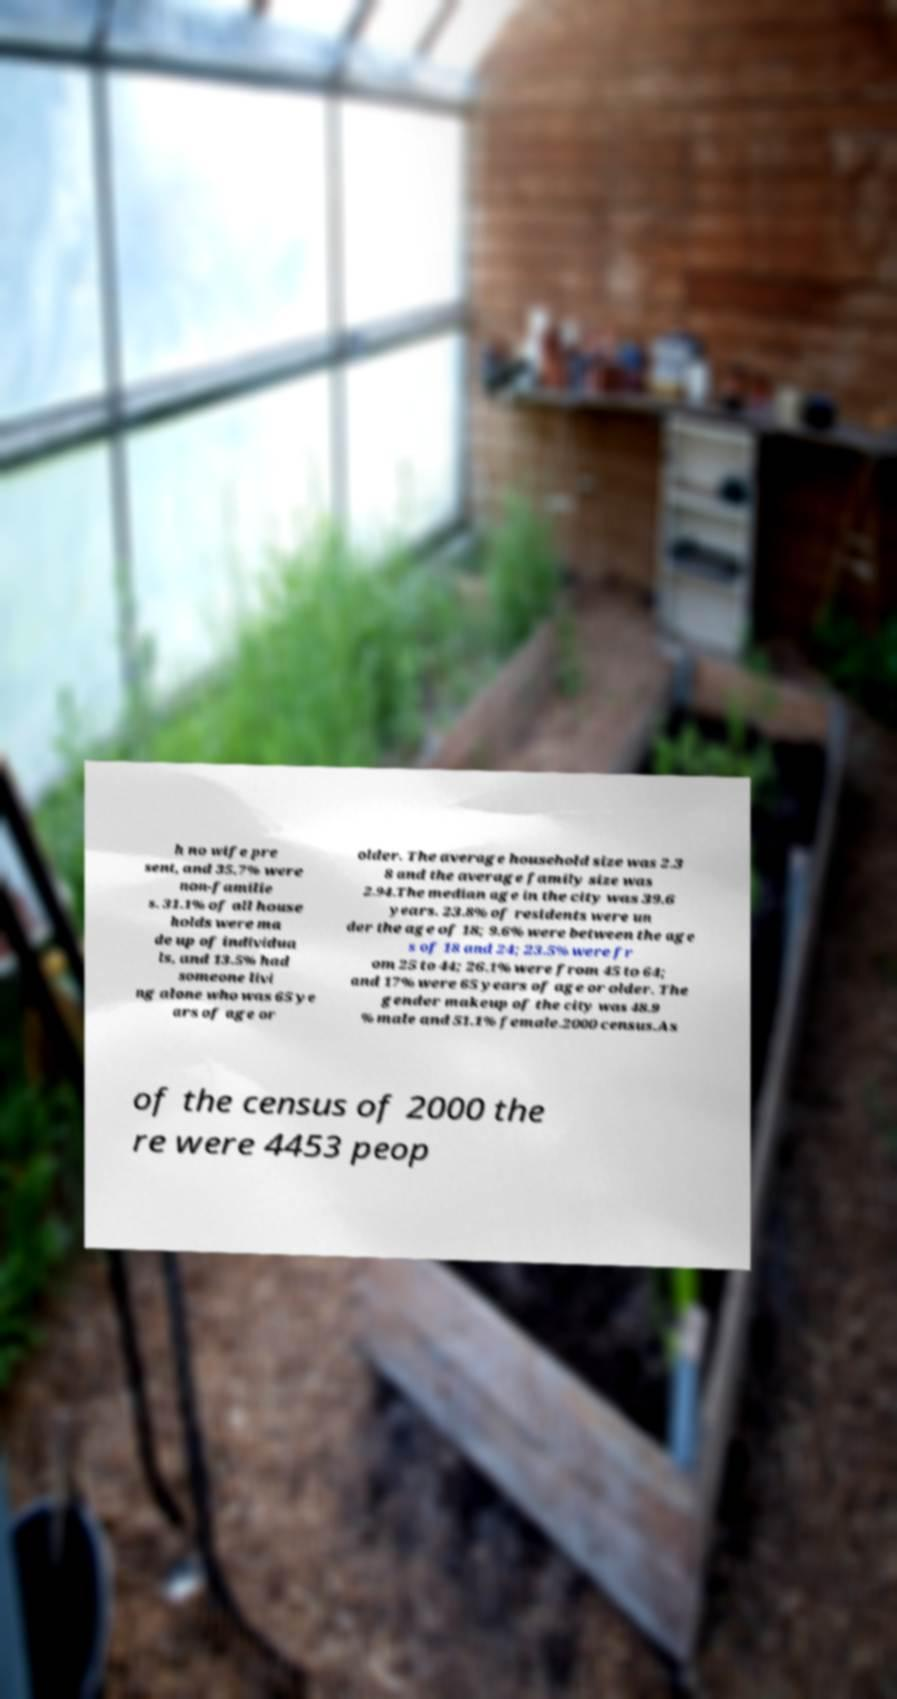What messages or text are displayed in this image? I need them in a readable, typed format. h no wife pre sent, and 35.7% were non-familie s. 31.1% of all house holds were ma de up of individua ls, and 13.5% had someone livi ng alone who was 65 ye ars of age or older. The average household size was 2.3 8 and the average family size was 2.94.The median age in the city was 39.6 years. 23.8% of residents were un der the age of 18; 9.6% were between the age s of 18 and 24; 23.5% were fr om 25 to 44; 26.1% were from 45 to 64; and 17% were 65 years of age or older. The gender makeup of the city was 48.9 % male and 51.1% female.2000 census.As of the census of 2000 the re were 4453 peop 